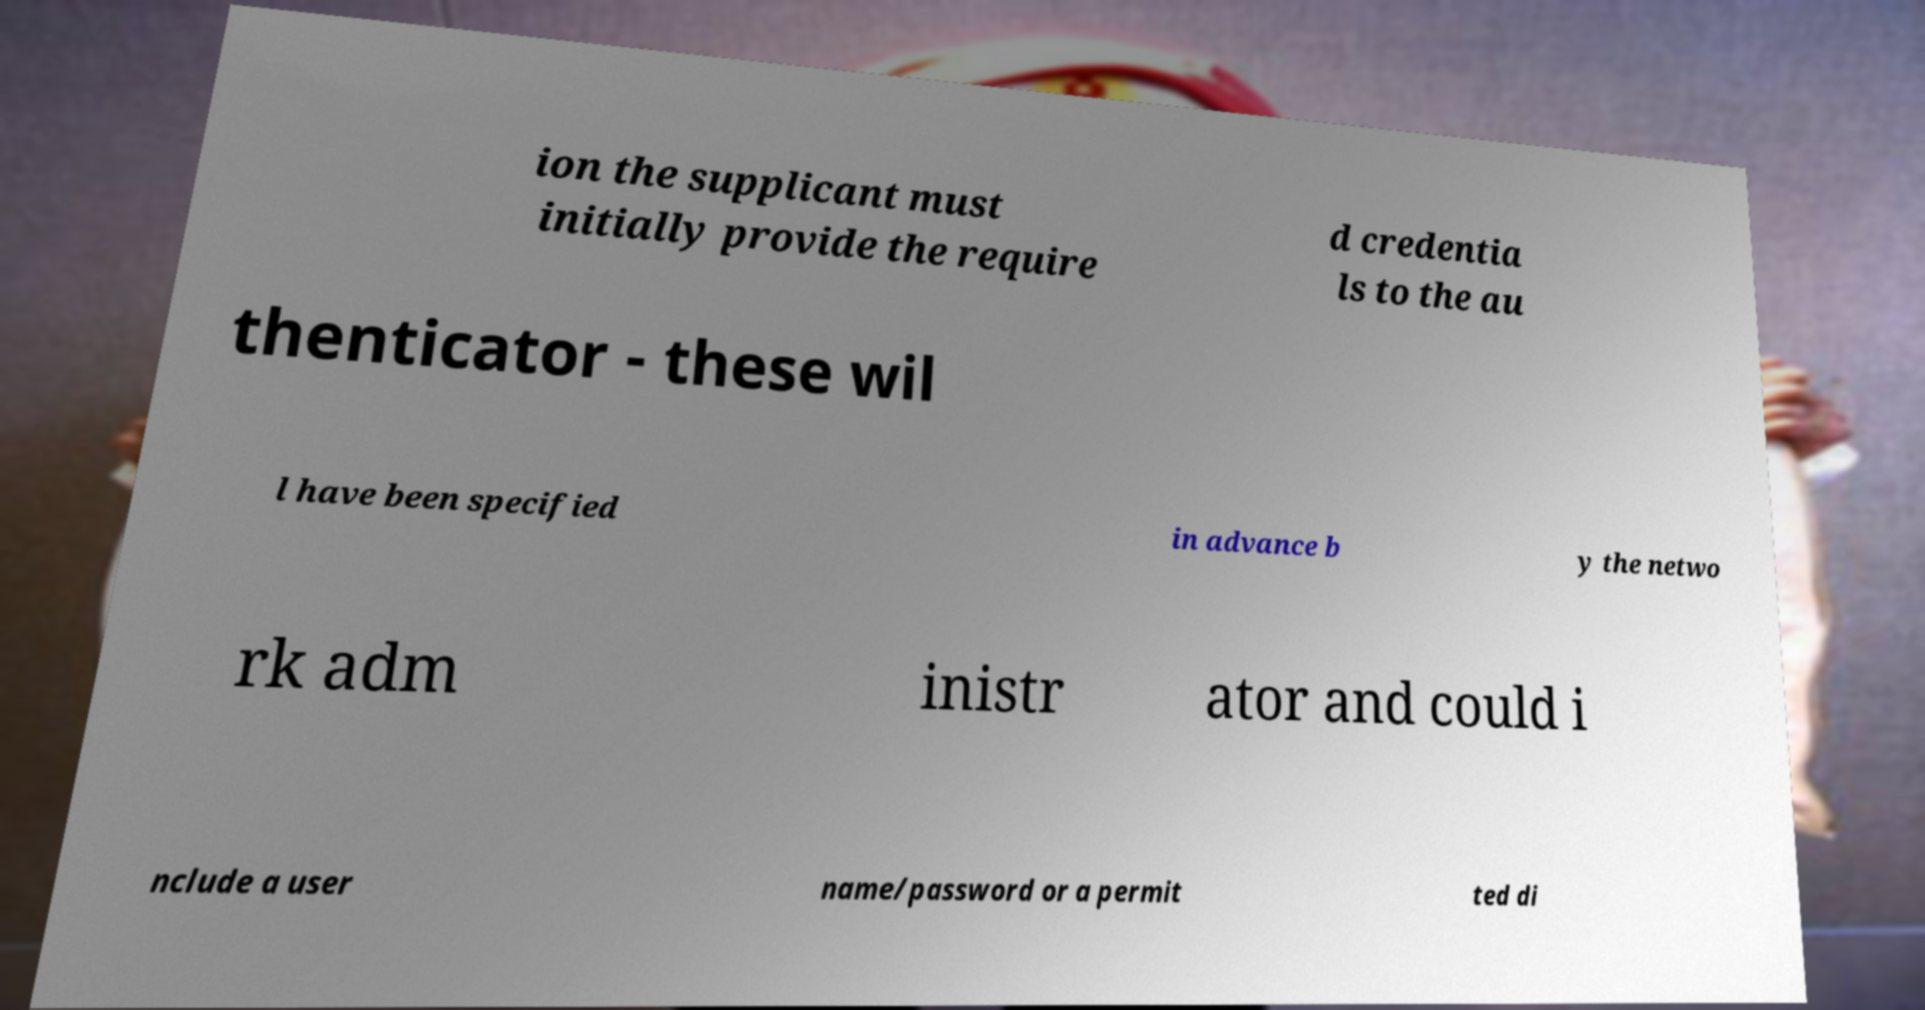There's text embedded in this image that I need extracted. Can you transcribe it verbatim? ion the supplicant must initially provide the require d credentia ls to the au thenticator - these wil l have been specified in advance b y the netwo rk adm inistr ator and could i nclude a user name/password or a permit ted di 